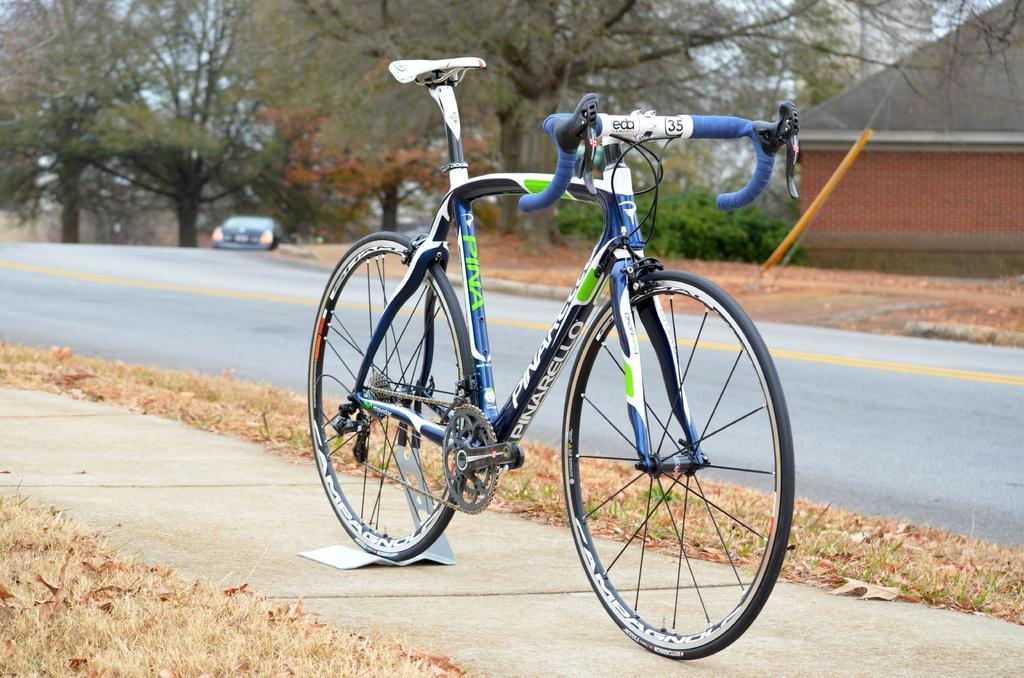What is the main object in the image? There is a bicycle in the image. Where is the bicycle located? The bicycle is on the sidewalk. What other structures or objects can be seen in the image? There is a house and a car on the road. What type of vegetation is present in the image? Trees are present on the side of the road. How many apples are hanging from the trees in the image? There are no apples visible in the image; only trees are present. Can you see a monkey climbing the trees in the image? There is no monkey present in the image; only trees are visible. 